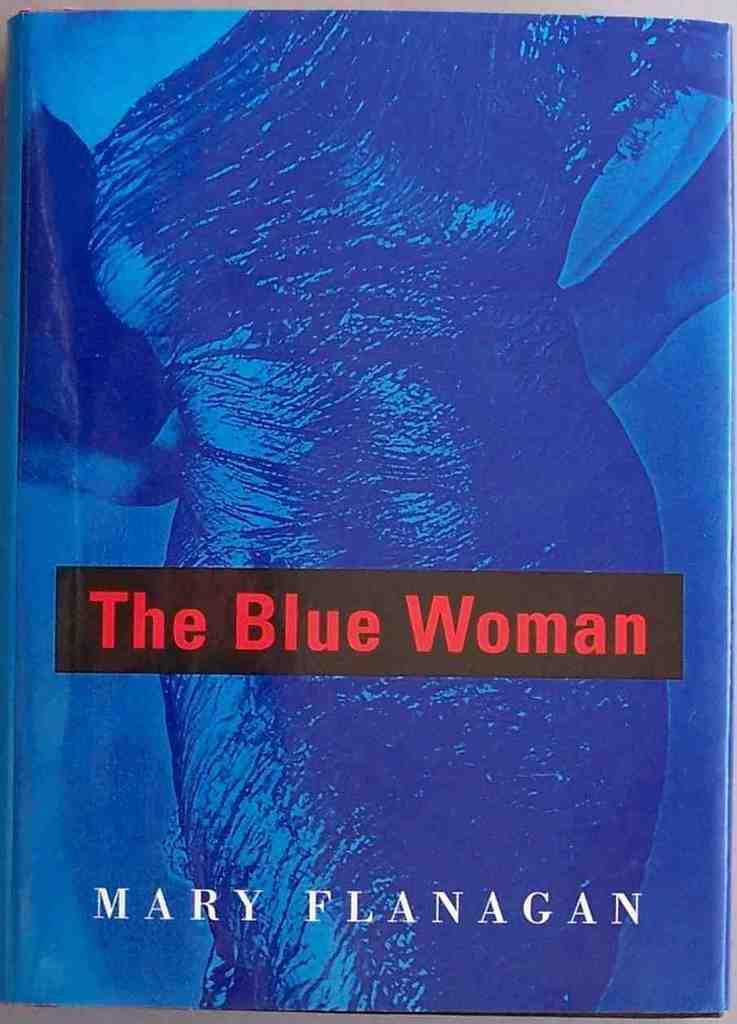What color is the woman?
Your response must be concise. Blue. 